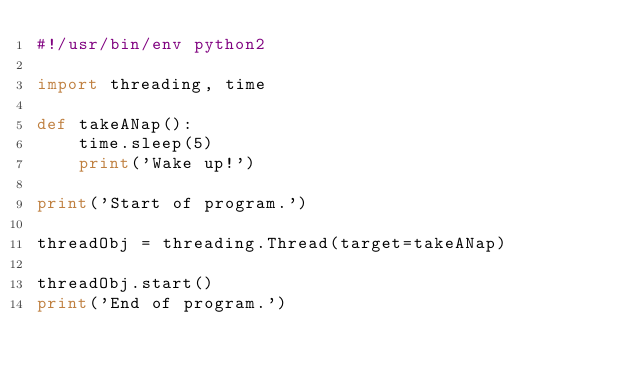<code> <loc_0><loc_0><loc_500><loc_500><_Python_>#!/usr/bin/env python2

import threading, time

def takeANap():
    time.sleep(5)
    print('Wake up!')

print('Start of program.')

threadObj = threading.Thread(target=takeANap)

threadObj.start()
print('End of program.')
</code> 